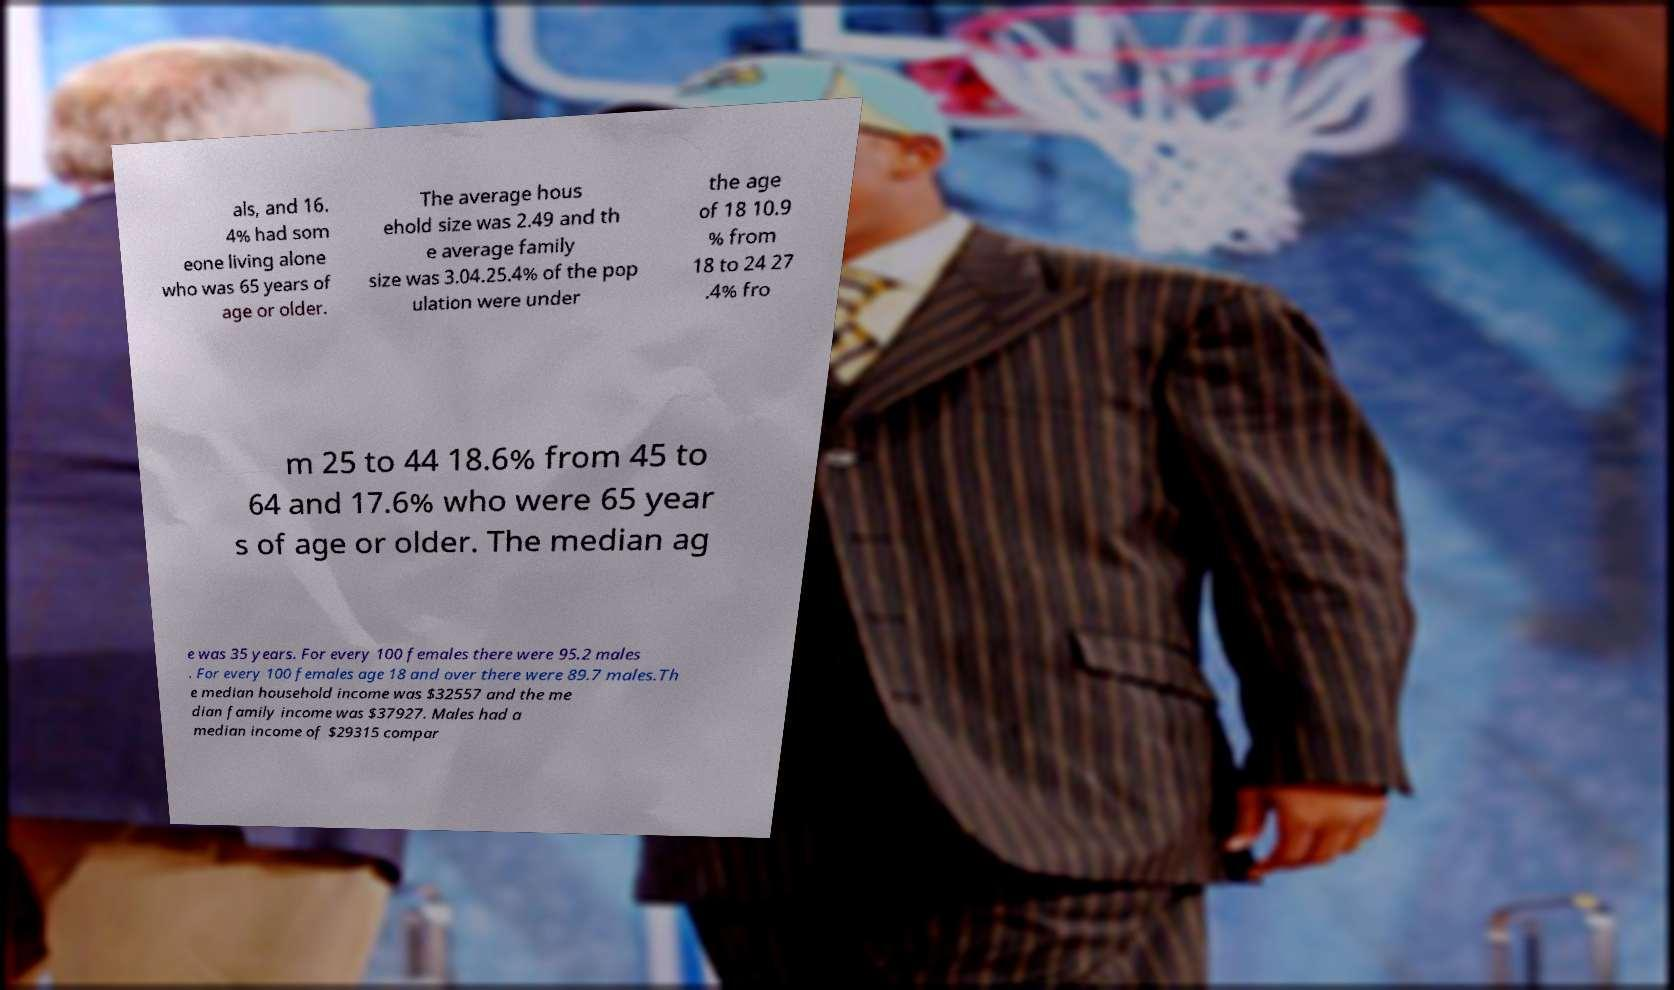Can you read and provide the text displayed in the image?This photo seems to have some interesting text. Can you extract and type it out for me? als, and 16. 4% had som eone living alone who was 65 years of age or older. The average hous ehold size was 2.49 and th e average family size was 3.04.25.4% of the pop ulation were under the age of 18 10.9 % from 18 to 24 27 .4% fro m 25 to 44 18.6% from 45 to 64 and 17.6% who were 65 year s of age or older. The median ag e was 35 years. For every 100 females there were 95.2 males . For every 100 females age 18 and over there were 89.7 males.Th e median household income was $32557 and the me dian family income was $37927. Males had a median income of $29315 compar 